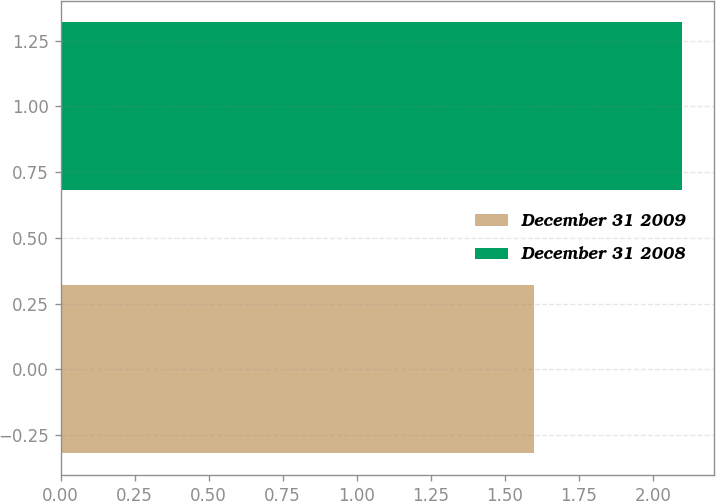Convert chart. <chart><loc_0><loc_0><loc_500><loc_500><bar_chart><fcel>December 31 2009<fcel>December 31 2008<nl><fcel>1.6<fcel>2.1<nl></chart> 